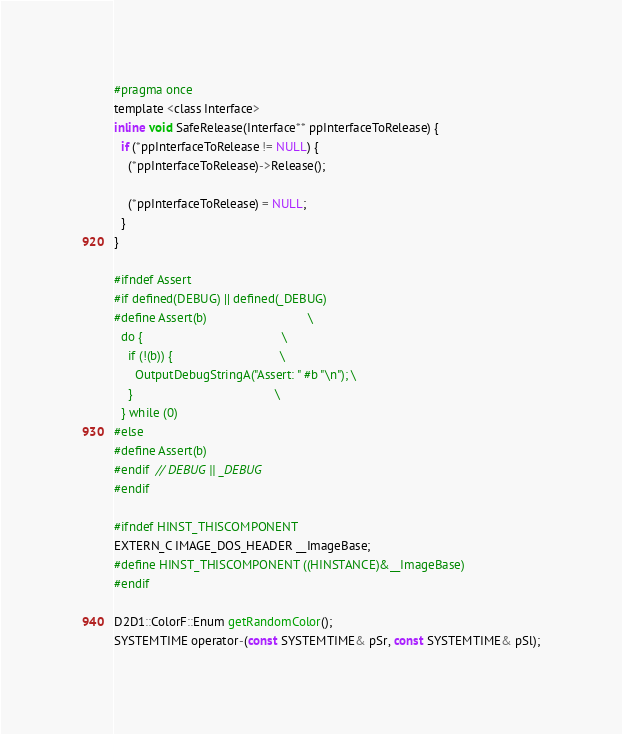<code> <loc_0><loc_0><loc_500><loc_500><_C_>#pragma once
template <class Interface>
inline void SafeRelease(Interface** ppInterfaceToRelease) {
  if (*ppInterfaceToRelease != NULL) {
    (*ppInterfaceToRelease)->Release();

    (*ppInterfaceToRelease) = NULL;
  }
}

#ifndef Assert
#if defined(DEBUG) || defined(_DEBUG)
#define Assert(b)                             \
  do {                                        \
    if (!(b)) {                               \
      OutputDebugStringA("Assert: " #b "\n"); \
    }                                         \
  } while (0)
#else
#define Assert(b)
#endif  // DEBUG || _DEBUG
#endif

#ifndef HINST_THISCOMPONENT
EXTERN_C IMAGE_DOS_HEADER __ImageBase;
#define HINST_THISCOMPONENT ((HINSTANCE)&__ImageBase)
#endif

D2D1::ColorF::Enum getRandomColor();
SYSTEMTIME operator-(const SYSTEMTIME& pSr, const SYSTEMTIME& pSl);
</code> 